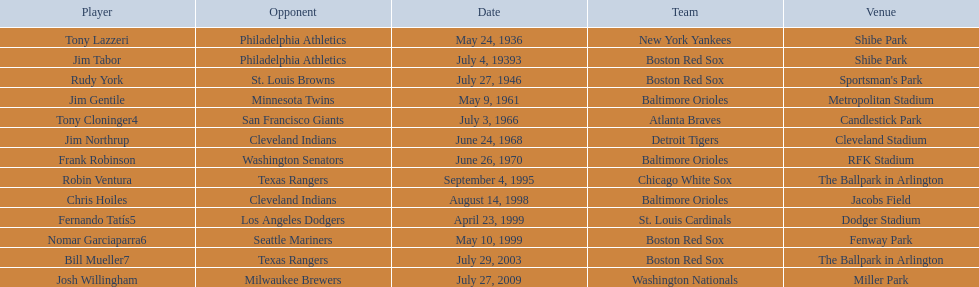Who are the opponents of the boston red sox during baseball home run records? Philadelphia Athletics, St. Louis Browns, Seattle Mariners, Texas Rangers. Of those which was the opponent on july 27, 1946? St. Louis Browns. 